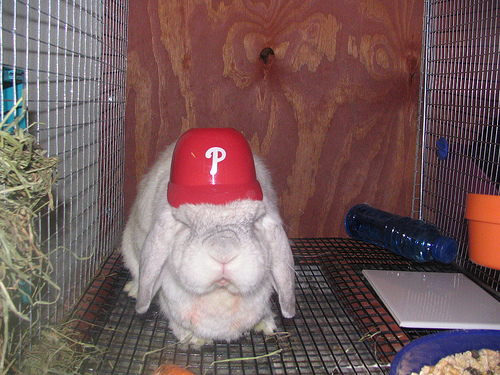<image>
Can you confirm if the blue object is behind the bowl? Yes. From this viewpoint, the blue object is positioned behind the bowl, with the bowl partially or fully occluding the blue object. 